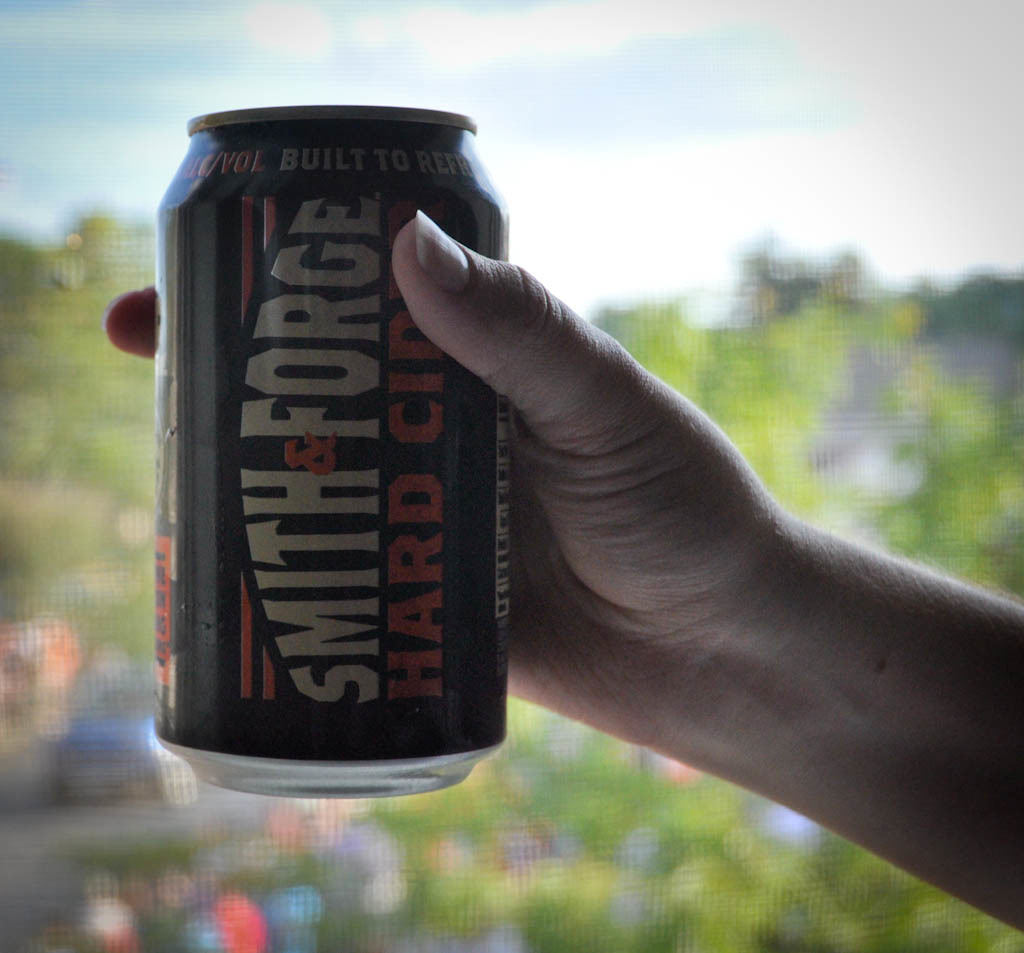What type of beverage is shown in the image and what details are visible on its label? The image shows a can of Smith & Forge hard cider, characterized by its bold, gothic-style label which includes phrases like 'Built to Refresh' and 'Hard Cider.' What does the setting suggest about when and where this beverage might be enjoyed? The background features a daylight scene with trees and a blurred outdoor setting, suggesting that this beverage might be enjoyed during a relaxed day, possibly at an outdoor gathering or during a casual outing. 